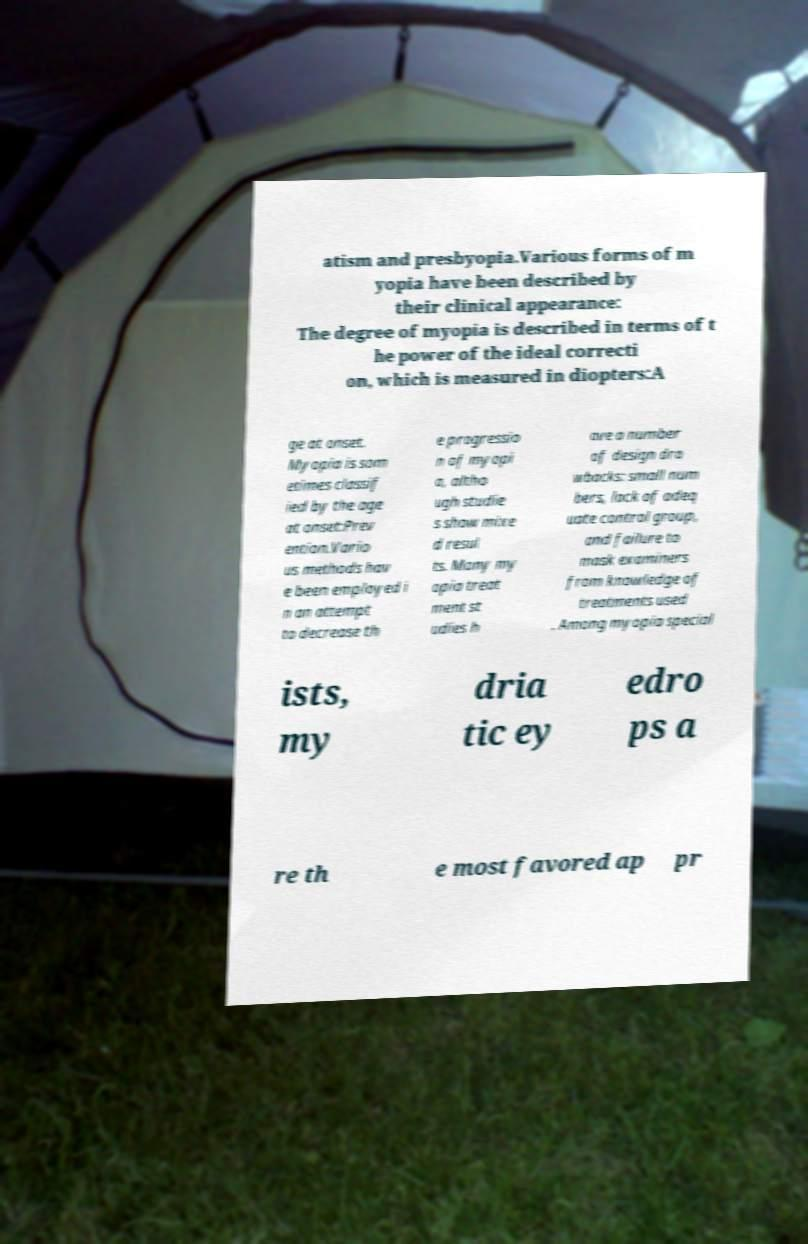Can you read and provide the text displayed in the image?This photo seems to have some interesting text. Can you extract and type it out for me? atism and presbyopia.Various forms of m yopia have been described by their clinical appearance: The degree of myopia is described in terms of t he power of the ideal correcti on, which is measured in diopters:A ge at onset. Myopia is som etimes classif ied by the age at onset:Prev ention.Vario us methods hav e been employed i n an attempt to decrease th e progressio n of myopi a, altho ugh studie s show mixe d resul ts. Many my opia treat ment st udies h ave a number of design dra wbacks: small num bers, lack of adeq uate control group, and failure to mask examiners from knowledge of treatments used . Among myopia special ists, my dria tic ey edro ps a re th e most favored ap pr 